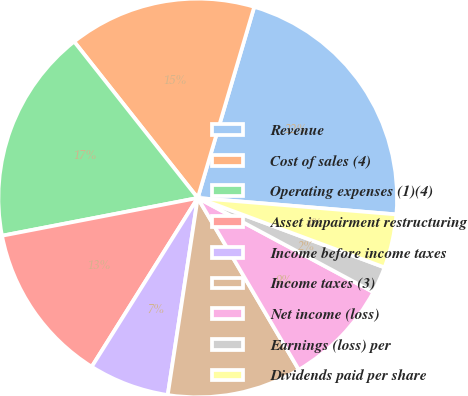Convert chart to OTSL. <chart><loc_0><loc_0><loc_500><loc_500><pie_chart><fcel>Revenue<fcel>Cost of sales (4)<fcel>Operating expenses (1)(4)<fcel>Asset impairment restructuring<fcel>Income before income taxes<fcel>Income taxes (3)<fcel>Net income (loss)<fcel>Earnings (loss) per<fcel>Dividends paid per share<nl><fcel>21.74%<fcel>15.22%<fcel>17.39%<fcel>13.04%<fcel>6.52%<fcel>10.87%<fcel>8.7%<fcel>2.17%<fcel>4.35%<nl></chart> 